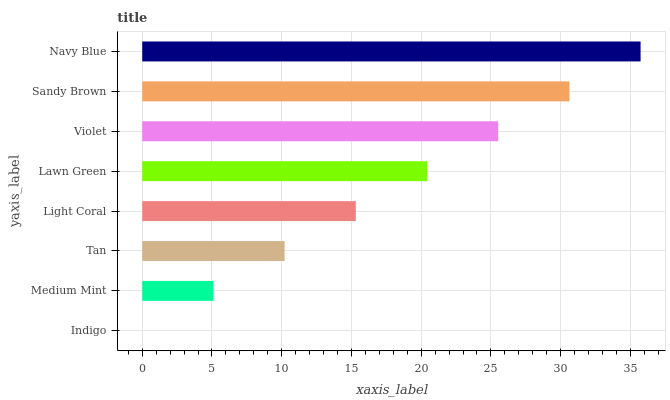Is Indigo the minimum?
Answer yes or no. Yes. Is Navy Blue the maximum?
Answer yes or no. Yes. Is Medium Mint the minimum?
Answer yes or no. No. Is Medium Mint the maximum?
Answer yes or no. No. Is Medium Mint greater than Indigo?
Answer yes or no. Yes. Is Indigo less than Medium Mint?
Answer yes or no. Yes. Is Indigo greater than Medium Mint?
Answer yes or no. No. Is Medium Mint less than Indigo?
Answer yes or no. No. Is Lawn Green the high median?
Answer yes or no. Yes. Is Light Coral the low median?
Answer yes or no. Yes. Is Tan the high median?
Answer yes or no. No. Is Sandy Brown the low median?
Answer yes or no. No. 